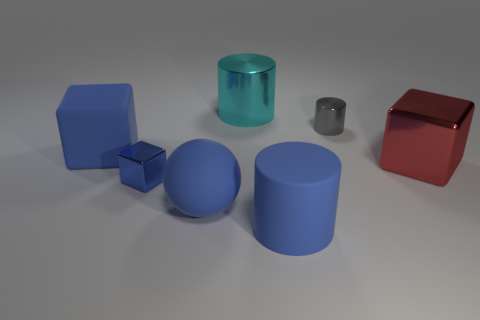Add 1 rubber objects. How many objects exist? 8 Subtract all cylinders. How many objects are left? 4 Subtract all tiny gray shiny cylinders. Subtract all tiny cylinders. How many objects are left? 5 Add 5 cyan metal things. How many cyan metal things are left? 6 Add 6 large cyan metal spheres. How many large cyan metal spheres exist? 6 Subtract 0 purple cylinders. How many objects are left? 7 